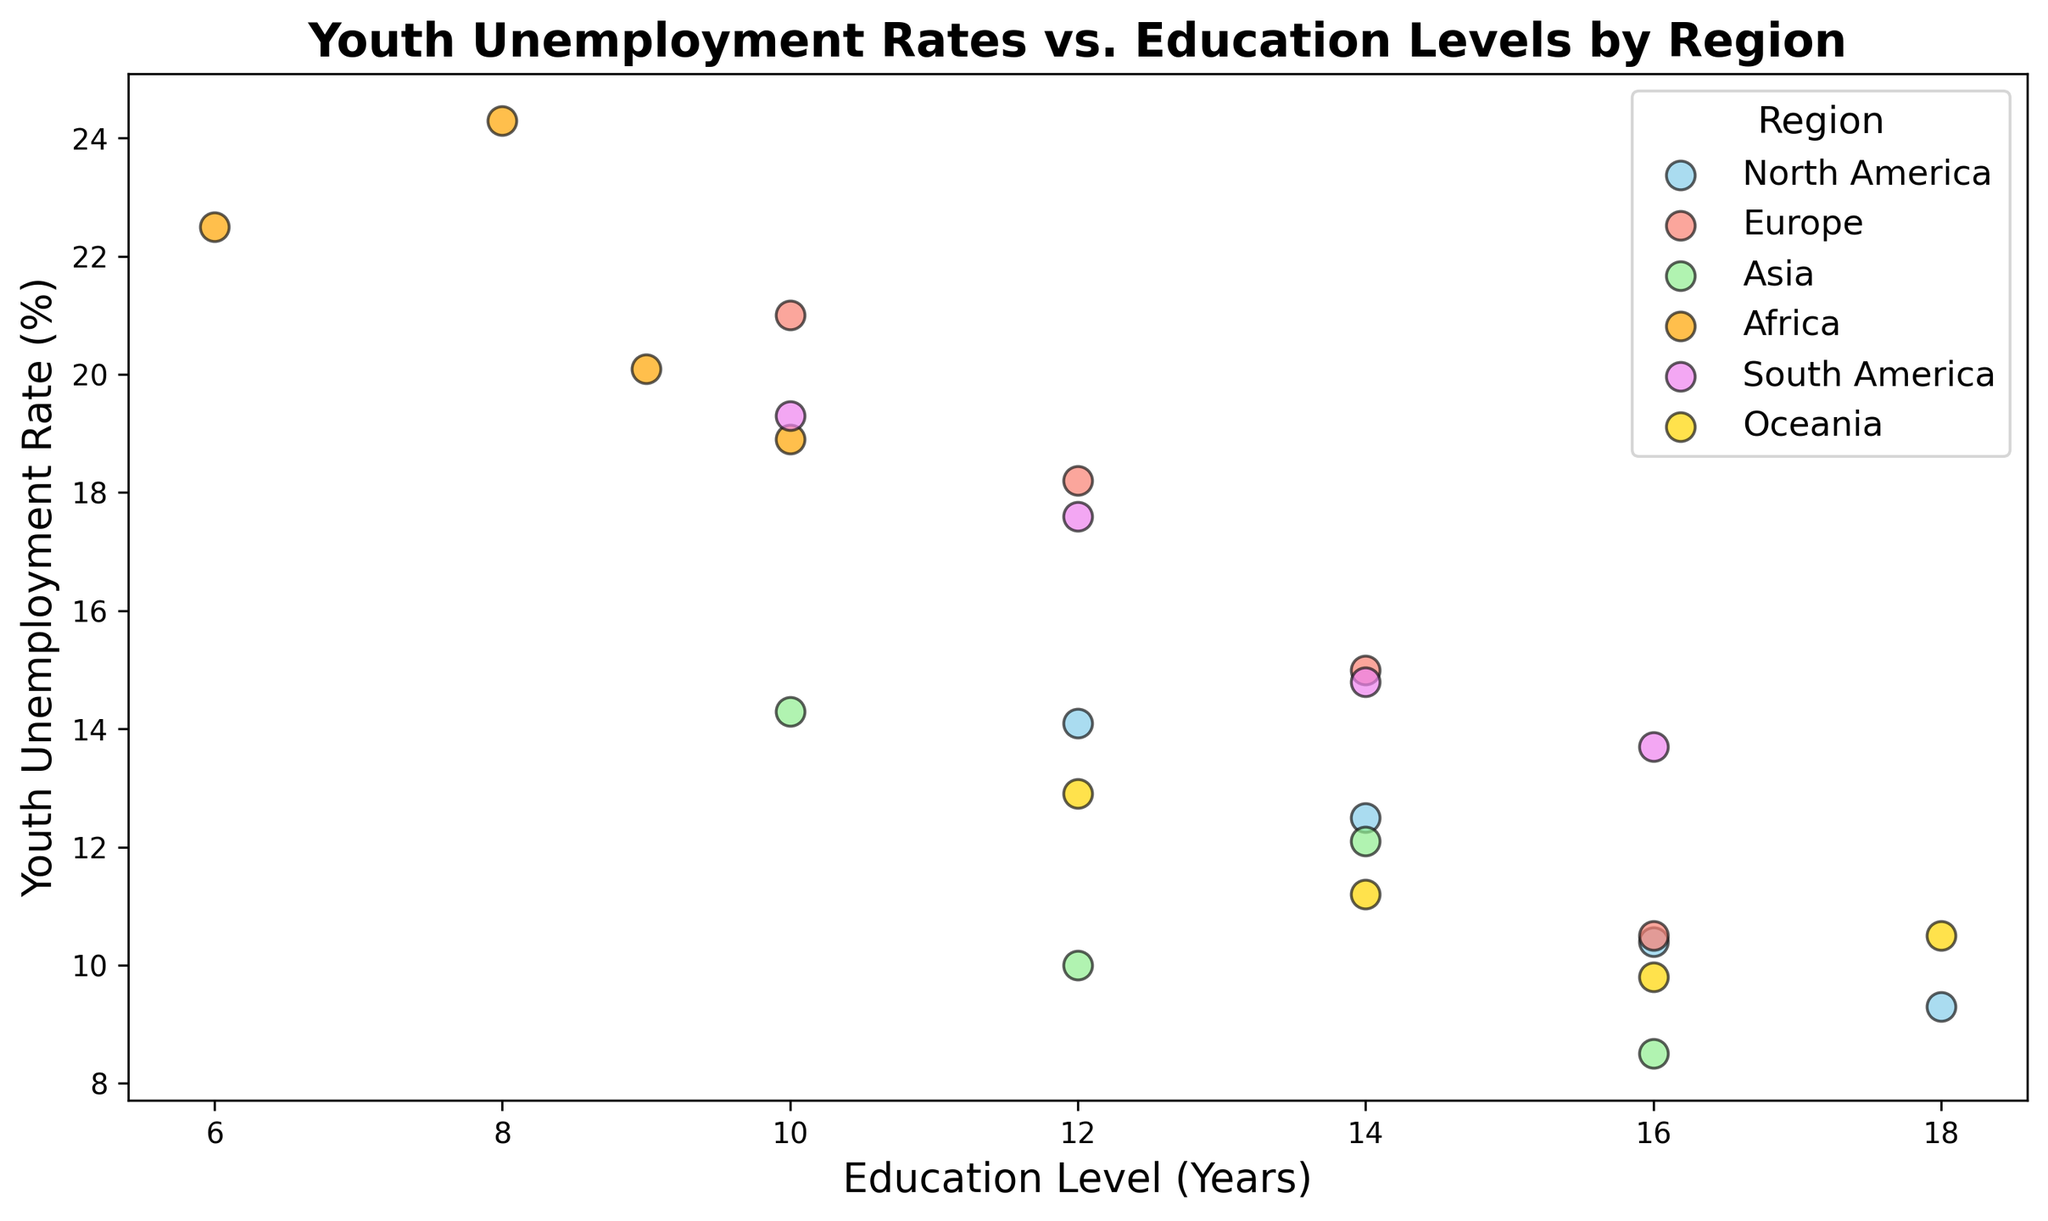What's the overall trend between education level and youth unemployment rate across all regions? Most of the points show that as the education level increases, the youth unemployment rate tends to decrease. However, there are some exceptions.
Answer: Decreasing Which region has the highest youth unemployment rate and what is the corresponding education level? Looking at the data points, Africa has the highest youth unemployment rate of 24.3%, and the corresponding education level is 8 years.
Answer: Africa, 8 years Among the continents, which has the lowest youth unemployment rate and what is the corresponding education level? The scatter plot shows that Asia has the lowest youth unemployment rate of 8.5%, and the corresponding education level is 16 years.
Answer: Asia, 16 years Is there any region where higher education levels are associated with higher unemployment rates? In Europe, for instance, the scatter plot data shows that an education level of 14 years has a youth unemployment rate of 15.0%, but an education level of 10 years is associated with a higher unemployment rate of 21.0%. This suggests that there are cases where higher education does not correlate with lower unemployment rates in Europe.
Answer: Europe What is the average youth unemployment rate in North America for data points with an education level of 14 years or higher? North America has data points with 14, 16, and 18 years of education level at corresponding youth unemployment rates of 12.5%, 10.4%, and 9.3% respectively. The average is calculated as (12.5 + 10.4 + 9.3)/3 = 10.73%.
Answer: 10.73% Compare the average youth unemployment rate in Africa and Oceania. Africa has data points with youth unemployment rates of 24.3%, 18.9%, 22.5%, and 20.1%. The average is (24.3 + 18.9 + 22.5 + 20.1)/4 = 21.45%. Oceania has data points with youth unemployment rates of 11.2%, 9.8%, 12.9%, 10.5%. The average is (11.2 + 9.8 + 12.9 + 10.5)/4 = 11.1%. Comparing these averages, Africa has a higher youth unemployment rate compared to Oceania.
Answer: Africa: 21.45%, Oceania: 11.1% Which region has the widest range of youth unemployment rates? To find the range, we subtract the minimum value from the maximum value for each region:
- North America: 14.1% - 9.3% = 4.8%
- Europe: 21.0% - 10.5% = 10.5%
- Asia: 14.3% - 8.5% = 5.8%
- Africa: 24.3% - 18.9% = 5.4%
- South America: 19.3% - 13.7% = 5.6%
- Oceania: 12.9% - 9.8% = 3.1%
Therefore, Europe has the widest range of youth unemployment rates.
Answer: Europe What is the median education level for the data points from South America? The education levels for South America are 12, 14, 10, and 16 years. Arranging them in order: 10, 12, 14, 16, the median falls between 12 and 14, so (12+14)/2 = 13 years.
Answer: 13 years 